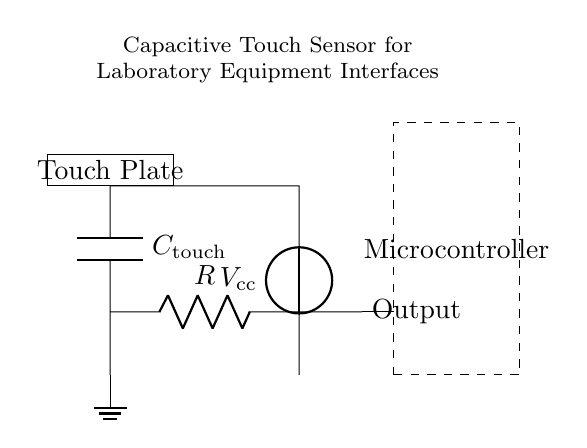What is the value of the touch capacitor? The touch capacitor is labeled as C_touch in the diagram. There is no specific numerical value provided in the circuit; it's just a symbolic representation.
Answer: C_touch What is the purpose of the resistor in this circuit? The resistor is used in conjunction with the capacitor to create an RC time constant, which determines the charge and discharge rate of the capacitor, influencing the responsiveness of the touch sensor.
Answer: To create an RC time constant What is the output component connected to? The output of the circuit is connected to the microcontroller, which processes the signal generated by the capacitive touch sensor.
Answer: Microcontroller What does the voltage source represent in this circuit? The voltage source labeled V_cc supplies the necessary power for the circuit to operate, providing the voltage for the touch sensing mechanism.
Answer: Power supply What happens when the touch plate is activated? When the touch plate is activated, it alters the capacitance sensed by the circuit, leading to a change in the voltage output, which the microcontroller detects for interaction purposes.
Answer: Changes voltage output What is the role of the microcontroller in this circuit? The microcontroller processes the output signal from the touch sensor to determine whether a touch has occurred and then responds accordingly, such as triggering an action or changing states in connected equipment.
Answer: Process output signal How does the charge state of the capacitor affect the circuit operation? The charge state determines the voltage across the capacitor, impacting how the microcontroller interprets the touch input. A higher charge would indicate a stronger touch signal, while a lower charge might indicate no touch.
Answer: Affects voltage interpretation 